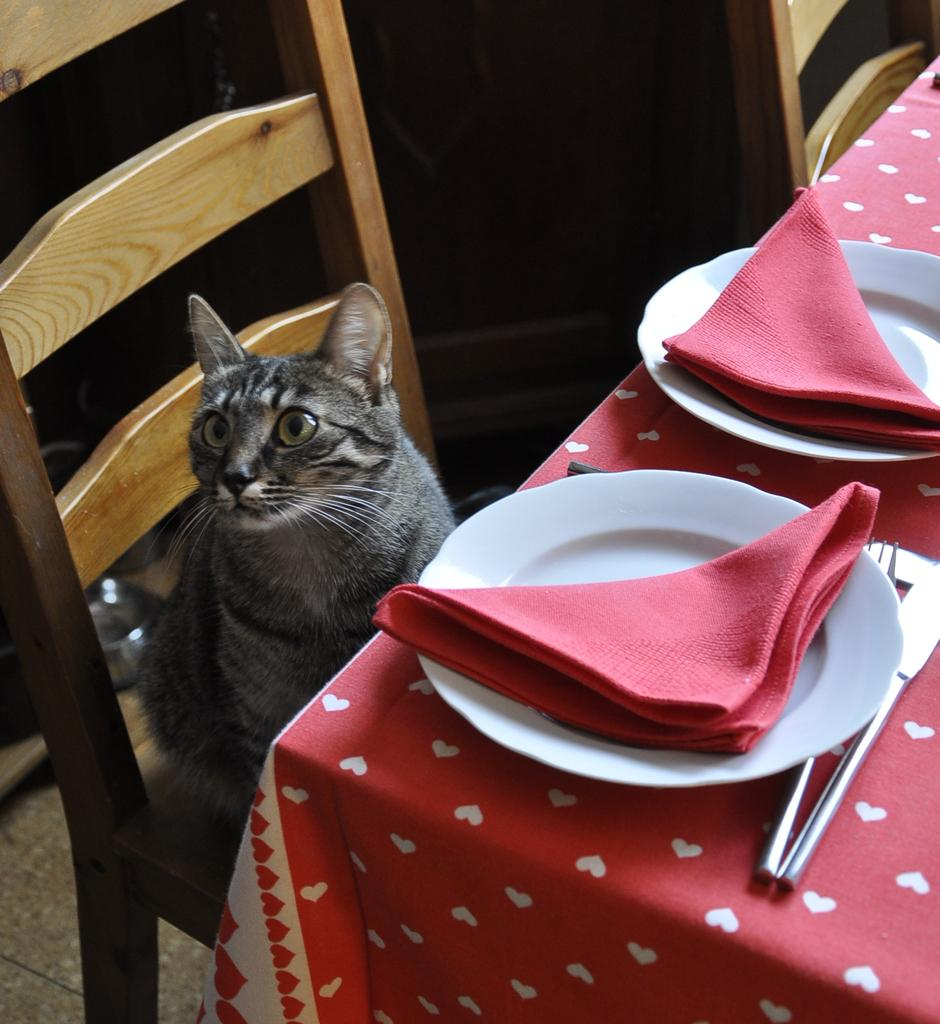What type of animal is in the image? There is a cat in the image. Where is the cat sitting? The cat is sitting on a chair. What is near the chair? The chair is near a table. What items can be seen on the table? There is a fork, a knife, a plate, and a cloth on the table. What type of print can be seen on the rail in the image? There is no rail present in the image, and therefore no print can be observed. 